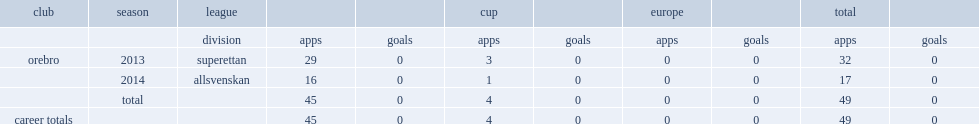Which club did ayanda nkili play for in 2013? Orebro. 